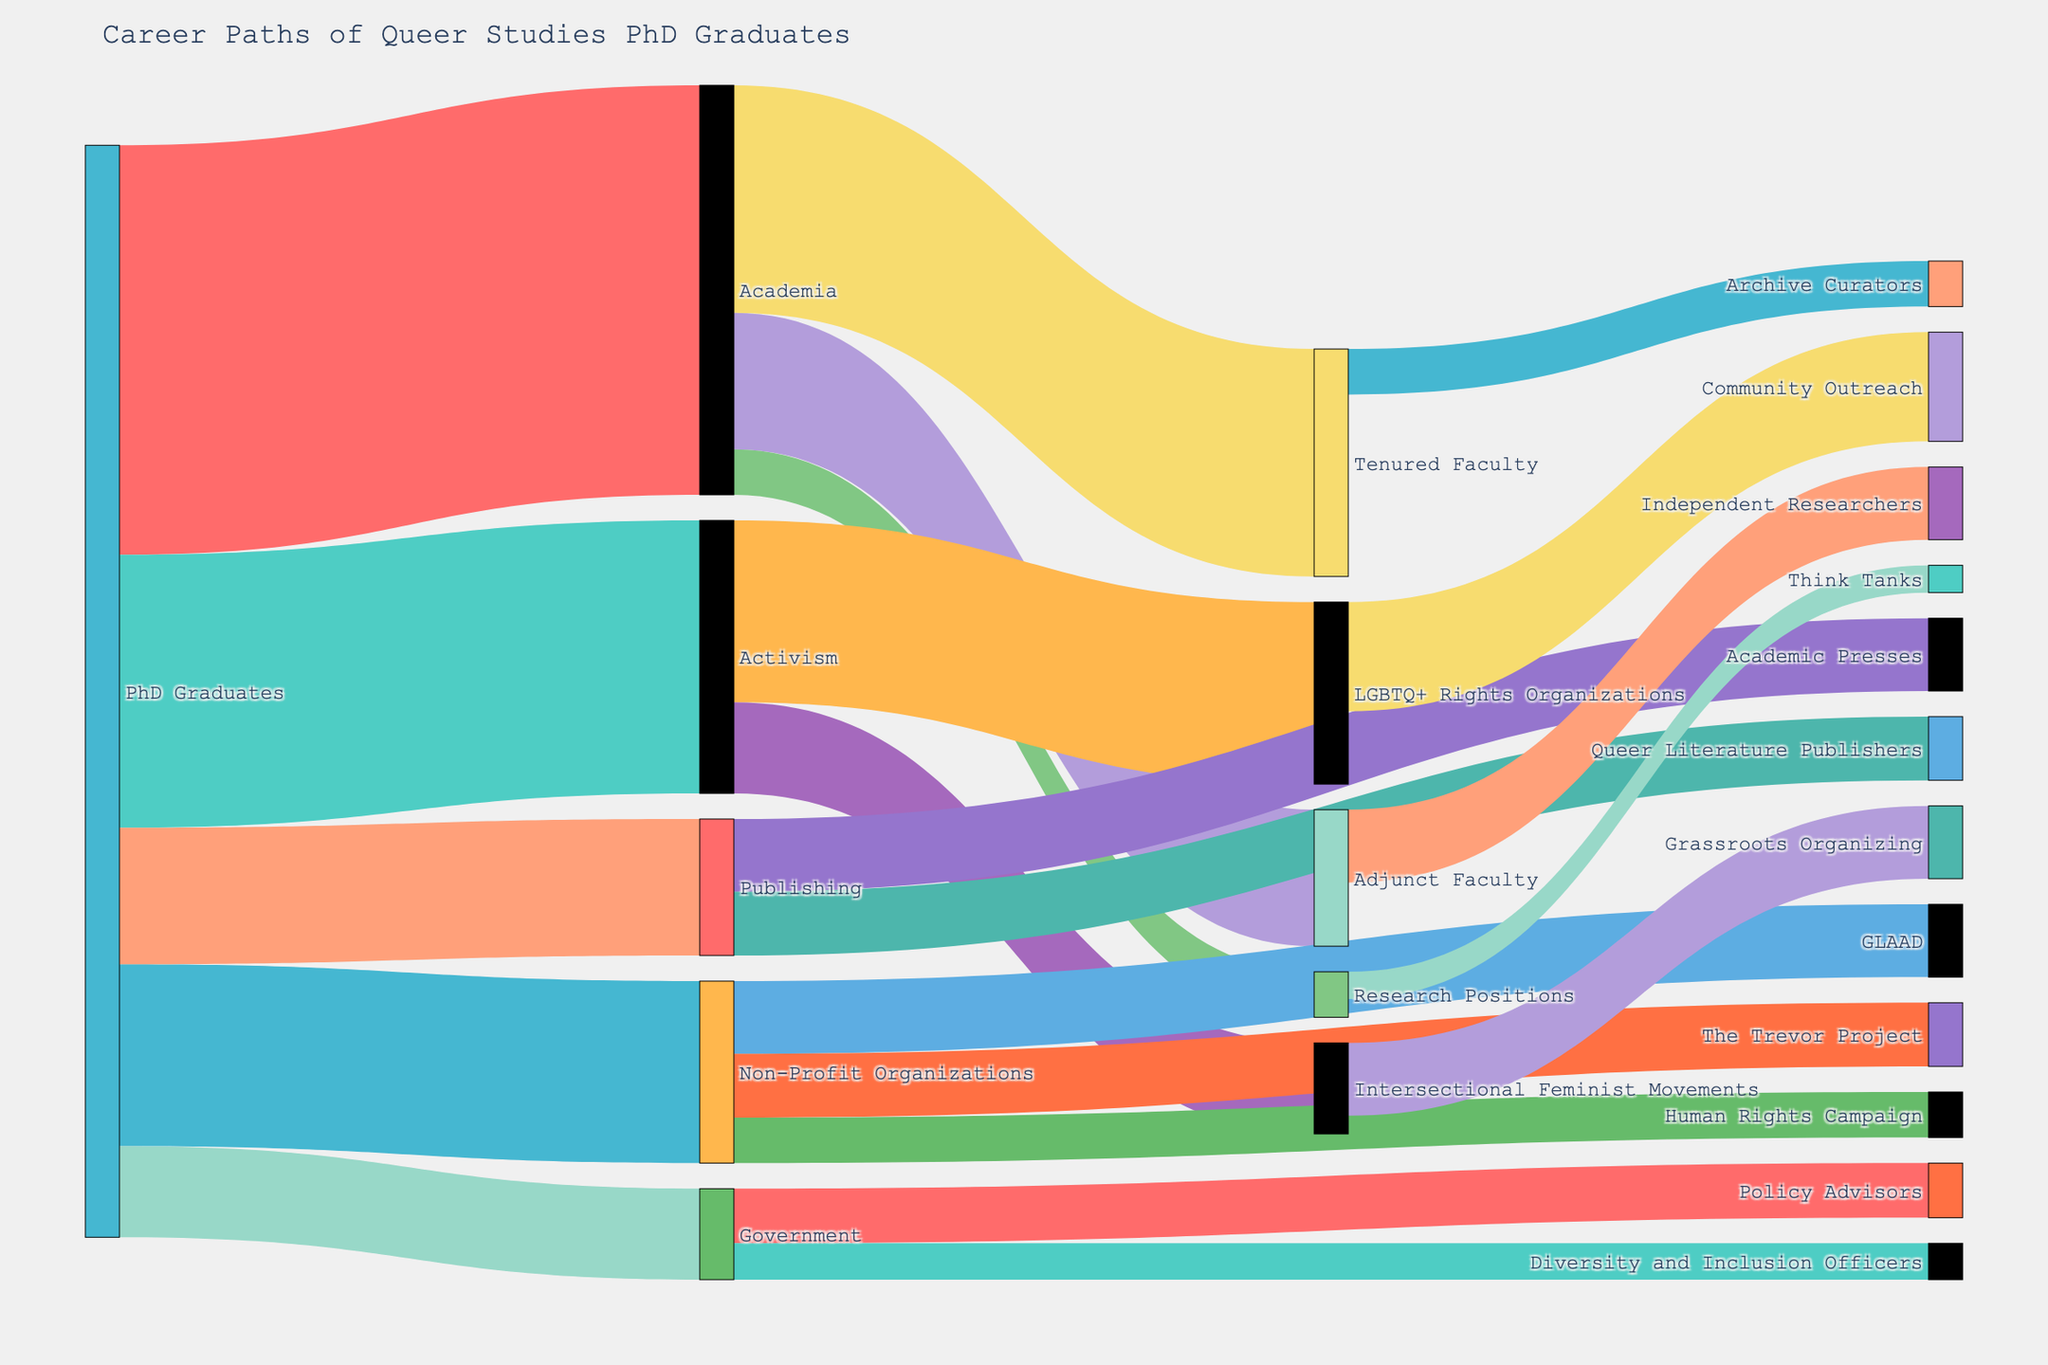Which sector has the highest number of Queer Studies PhD Graduates transitioning into it directly after graduation? By examining the diagram, we see that from the 'PhD Graduates' node, the link with the greatest thickness (or value) leads to 'Academia' with a value of 45.
Answer: Academia How many PhD Graduates pursue careers in academia or activism? To find this, we need to sum the values of those transitioning to 'Academia' (45) and 'Activism' (30). So, 45 + 30 = 75.
Answer: 75 Among those who enter Academia, how many end up in Tenured Faculty positions? From the 'Academia' node, the link labeled 'Tenured Faculty' has a value of 25. This value represents the number of PhD Graduates who end up in Tenured Faculty positions.
Answer: 25 Which sector has the lowest number of PhD Graduates transitioning into it directly after graduation? Looking at all the initial paths from 'PhD Graduates', the link with the smallest value leads to 'Government' with a value of 10.
Answer: Government What is the total number of PhD Graduates who go on to work in the Government sector, including all subsequent transitions? First, there are 10 PhD Graduates who transition directly into 'Government'. Then, within 'Government,' there are 6 who become 'Policy Advisors' and 4 who become 'Diversity and Inclusion Officers'. Thus, the total is 10 + 6 + 4 = 20.
Answer: 20 How does the number of PhD Graduates in LGBTQ+ Rights Organizations compare to those in Intersectional Feminist Movements? From the 'Activism' node, 20 go to 'LGBTQ+ Rights Organizations' and 10 go to 'Intersectional Feminist Movements'. 20 is greater than 10.
Answer: 20 > 10 From those working in Non-Profit Organizations, which organization has the second highest number of PhD Graduates? In the 'Non-Profit Organizations' node, the values are 'GLAAD' (8), 'The Trevor Project' (7), and 'Human Rights Campaign' (5). The second highest value is 7, which corresponds to 'The Trevor Project'.
Answer: The Trevor Project Which post-graduation path (Tenured Faculty or Adjunct Faculty) leads to more independent roles (like Archive Curators or Independent Researchers)? After 'Academia,' 25 go to 'Tenured Faculty' and 15 go to 'Adjunct Faculty.' From 'Tenured Faculty,' 5 go to 'Archive Curators'. From 'Adjunct Faculty,' 8 become 'Independent Researchers'. Since 8 is greater than 5, 'Adjunct Faculty' leads to more independent roles.
Answer: Adjunct Faculty What is the combined number of PhD Graduates working in Activism fields (including sub-sectors)? From 'Activism' there are 20 in 'LGBTQ+ Rights Organizations' and 10 in 'Intersectional Feminist Movements'. Adding these gives 20 + 10 = 30 (same as direct transitions). Then, within 'LGBTQ+ Rights Organizations,' 12 work in 'Community Outreach' and in 'Intersectional Feminist Movements,' 8 in 'Grassroots Organizing'. Total: 30 + 12 + 8 = 50.
Answer: 50 